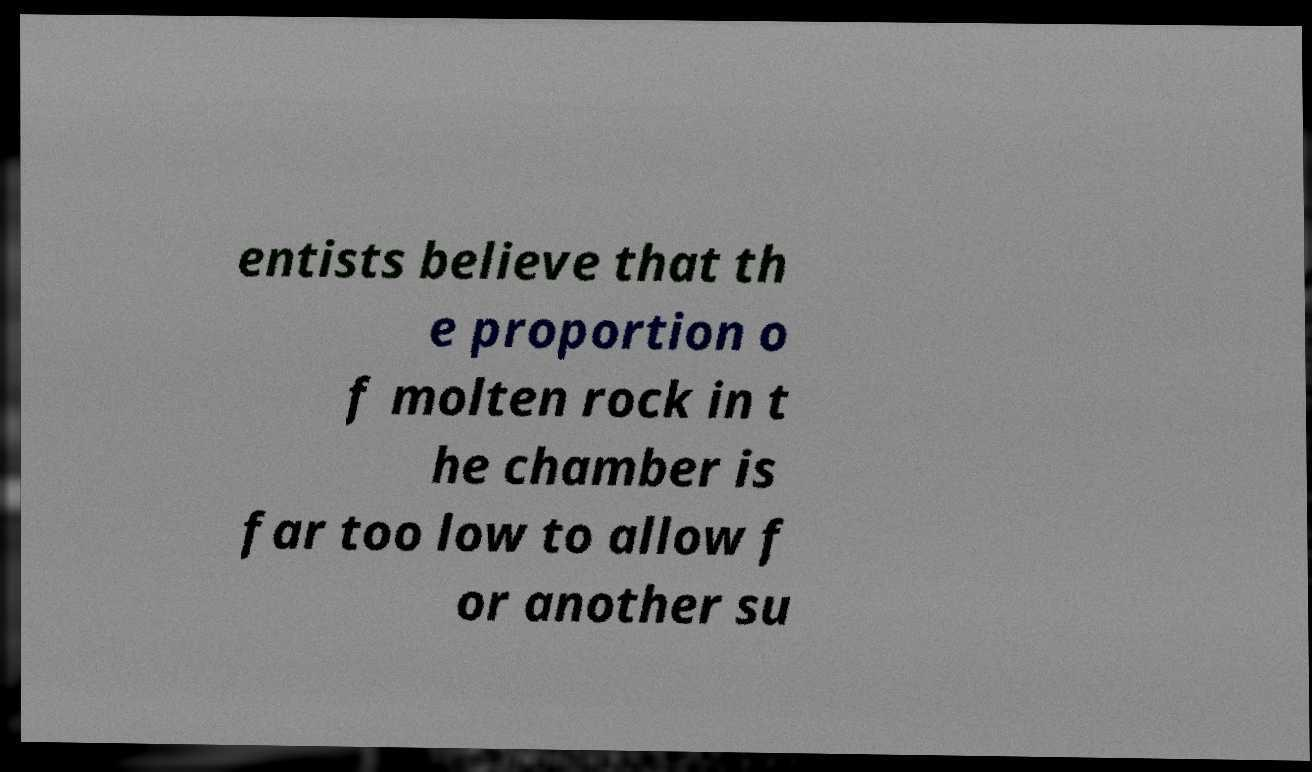For documentation purposes, I need the text within this image transcribed. Could you provide that? entists believe that th e proportion o f molten rock in t he chamber is far too low to allow f or another su 